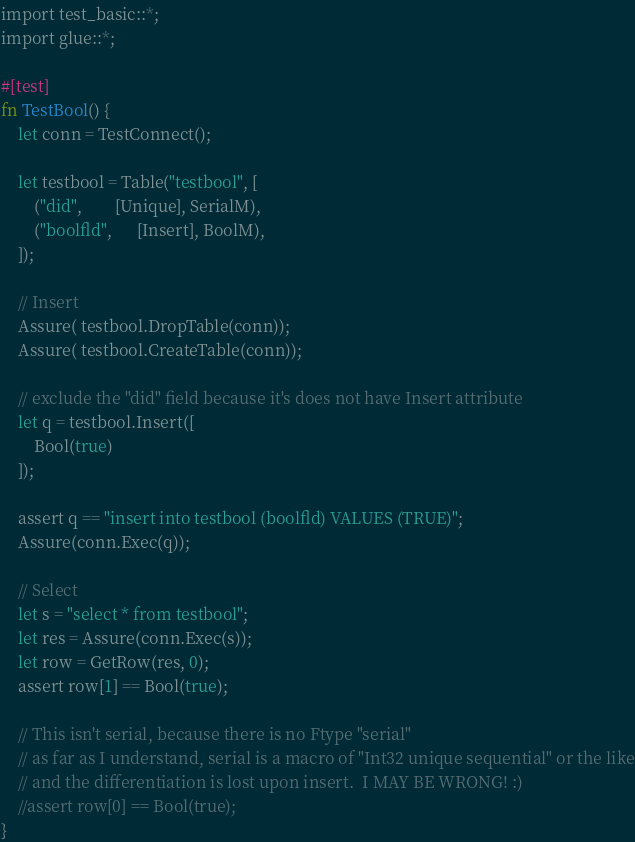Convert code to text. <code><loc_0><loc_0><loc_500><loc_500><_Rust_>import test_basic::*;
import glue::*;

#[test]
fn TestBool() {
    let conn = TestConnect();

    let testbool = Table("testbool", [
        ("did",        [Unique], SerialM),
        ("boolfld",      [Insert], BoolM),
    ]);

    // Insert
    Assure( testbool.DropTable(conn));
    Assure( testbool.CreateTable(conn));

    // exclude the "did" field because it's does not have Insert attribute
    let q = testbool.Insert([
        Bool(true)
    ]);
    
    assert q == "insert into testbool (boolfld) VALUES (TRUE)";
    Assure(conn.Exec(q));

    // Select
    let s = "select * from testbool";
    let res = Assure(conn.Exec(s));
    let row = GetRow(res, 0);  
    assert row[1] == Bool(true);

    // This isn't serial, because there is no Ftype "serial"
    // as far as I understand, serial is a macro of "Int32 unique sequential" or the like
    // and the differentiation is lost upon insert.  I MAY BE WRONG! :)
    //assert row[0] == Bool(true); 
}
</code> 